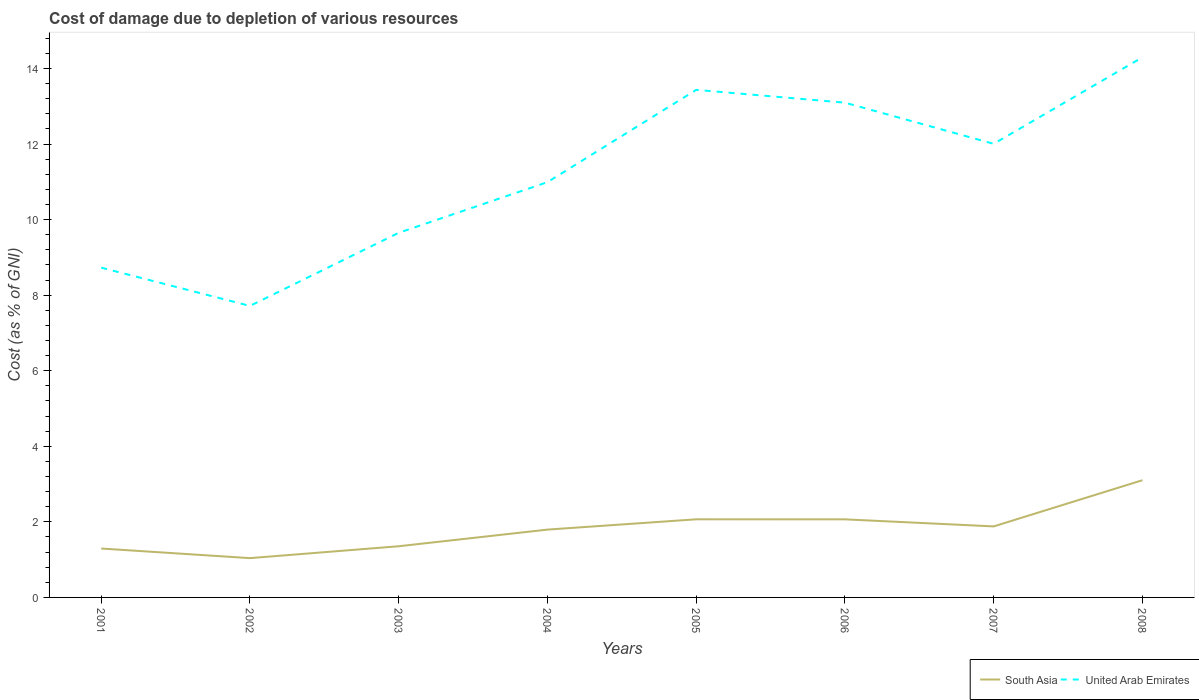How many different coloured lines are there?
Keep it short and to the point. 2. Does the line corresponding to South Asia intersect with the line corresponding to United Arab Emirates?
Keep it short and to the point. No. Across all years, what is the maximum cost of damage caused due to the depletion of various resources in South Asia?
Provide a short and direct response. 1.04. What is the total cost of damage caused due to the depletion of various resources in United Arab Emirates in the graph?
Your answer should be compact. -5.72. What is the difference between the highest and the second highest cost of damage caused due to the depletion of various resources in South Asia?
Offer a very short reply. 2.06. What is the difference between the highest and the lowest cost of damage caused due to the depletion of various resources in United Arab Emirates?
Ensure brevity in your answer.  4. Are the values on the major ticks of Y-axis written in scientific E-notation?
Provide a short and direct response. No. What is the title of the graph?
Keep it short and to the point. Cost of damage due to depletion of various resources. What is the label or title of the Y-axis?
Offer a very short reply. Cost (as % of GNI). What is the Cost (as % of GNI) in South Asia in 2001?
Keep it short and to the point. 1.29. What is the Cost (as % of GNI) in United Arab Emirates in 2001?
Your response must be concise. 8.73. What is the Cost (as % of GNI) in South Asia in 2002?
Ensure brevity in your answer.  1.04. What is the Cost (as % of GNI) of United Arab Emirates in 2002?
Your answer should be compact. 7.72. What is the Cost (as % of GNI) in South Asia in 2003?
Offer a terse response. 1.35. What is the Cost (as % of GNI) of United Arab Emirates in 2003?
Keep it short and to the point. 9.65. What is the Cost (as % of GNI) in South Asia in 2004?
Ensure brevity in your answer.  1.8. What is the Cost (as % of GNI) in United Arab Emirates in 2004?
Provide a short and direct response. 10.99. What is the Cost (as % of GNI) of South Asia in 2005?
Keep it short and to the point. 2.07. What is the Cost (as % of GNI) of United Arab Emirates in 2005?
Your response must be concise. 13.44. What is the Cost (as % of GNI) in South Asia in 2006?
Your response must be concise. 2.07. What is the Cost (as % of GNI) in United Arab Emirates in 2006?
Offer a very short reply. 13.1. What is the Cost (as % of GNI) of South Asia in 2007?
Your response must be concise. 1.88. What is the Cost (as % of GNI) of United Arab Emirates in 2007?
Provide a short and direct response. 12.01. What is the Cost (as % of GNI) of South Asia in 2008?
Make the answer very short. 3.1. What is the Cost (as % of GNI) of United Arab Emirates in 2008?
Provide a succinct answer. 14.3. Across all years, what is the maximum Cost (as % of GNI) in South Asia?
Your answer should be very brief. 3.1. Across all years, what is the maximum Cost (as % of GNI) in United Arab Emirates?
Your answer should be very brief. 14.3. Across all years, what is the minimum Cost (as % of GNI) of South Asia?
Provide a short and direct response. 1.04. Across all years, what is the minimum Cost (as % of GNI) of United Arab Emirates?
Your response must be concise. 7.72. What is the total Cost (as % of GNI) in South Asia in the graph?
Offer a terse response. 14.6. What is the total Cost (as % of GNI) in United Arab Emirates in the graph?
Keep it short and to the point. 89.93. What is the difference between the Cost (as % of GNI) of South Asia in 2001 and that in 2002?
Provide a succinct answer. 0.25. What is the difference between the Cost (as % of GNI) in United Arab Emirates in 2001 and that in 2002?
Offer a terse response. 1.01. What is the difference between the Cost (as % of GNI) in South Asia in 2001 and that in 2003?
Ensure brevity in your answer.  -0.06. What is the difference between the Cost (as % of GNI) in United Arab Emirates in 2001 and that in 2003?
Give a very brief answer. -0.92. What is the difference between the Cost (as % of GNI) in South Asia in 2001 and that in 2004?
Offer a terse response. -0.5. What is the difference between the Cost (as % of GNI) of United Arab Emirates in 2001 and that in 2004?
Give a very brief answer. -2.26. What is the difference between the Cost (as % of GNI) in South Asia in 2001 and that in 2005?
Make the answer very short. -0.77. What is the difference between the Cost (as % of GNI) of United Arab Emirates in 2001 and that in 2005?
Keep it short and to the point. -4.71. What is the difference between the Cost (as % of GNI) in South Asia in 2001 and that in 2006?
Provide a succinct answer. -0.77. What is the difference between the Cost (as % of GNI) in United Arab Emirates in 2001 and that in 2006?
Offer a terse response. -4.37. What is the difference between the Cost (as % of GNI) in South Asia in 2001 and that in 2007?
Offer a terse response. -0.59. What is the difference between the Cost (as % of GNI) of United Arab Emirates in 2001 and that in 2007?
Offer a very short reply. -3.28. What is the difference between the Cost (as % of GNI) of South Asia in 2001 and that in 2008?
Offer a terse response. -1.81. What is the difference between the Cost (as % of GNI) of United Arab Emirates in 2001 and that in 2008?
Keep it short and to the point. -5.57. What is the difference between the Cost (as % of GNI) in South Asia in 2002 and that in 2003?
Offer a terse response. -0.31. What is the difference between the Cost (as % of GNI) in United Arab Emirates in 2002 and that in 2003?
Give a very brief answer. -1.94. What is the difference between the Cost (as % of GNI) of South Asia in 2002 and that in 2004?
Make the answer very short. -0.76. What is the difference between the Cost (as % of GNI) of United Arab Emirates in 2002 and that in 2004?
Offer a terse response. -3.28. What is the difference between the Cost (as % of GNI) of South Asia in 2002 and that in 2005?
Give a very brief answer. -1.03. What is the difference between the Cost (as % of GNI) of United Arab Emirates in 2002 and that in 2005?
Give a very brief answer. -5.72. What is the difference between the Cost (as % of GNI) of South Asia in 2002 and that in 2006?
Your answer should be very brief. -1.03. What is the difference between the Cost (as % of GNI) in United Arab Emirates in 2002 and that in 2006?
Ensure brevity in your answer.  -5.38. What is the difference between the Cost (as % of GNI) in South Asia in 2002 and that in 2007?
Keep it short and to the point. -0.84. What is the difference between the Cost (as % of GNI) of United Arab Emirates in 2002 and that in 2007?
Provide a succinct answer. -4.29. What is the difference between the Cost (as % of GNI) of South Asia in 2002 and that in 2008?
Your answer should be very brief. -2.06. What is the difference between the Cost (as % of GNI) of United Arab Emirates in 2002 and that in 2008?
Make the answer very short. -6.58. What is the difference between the Cost (as % of GNI) in South Asia in 2003 and that in 2004?
Provide a succinct answer. -0.44. What is the difference between the Cost (as % of GNI) of United Arab Emirates in 2003 and that in 2004?
Offer a terse response. -1.34. What is the difference between the Cost (as % of GNI) of South Asia in 2003 and that in 2005?
Keep it short and to the point. -0.71. What is the difference between the Cost (as % of GNI) of United Arab Emirates in 2003 and that in 2005?
Make the answer very short. -3.78. What is the difference between the Cost (as % of GNI) of South Asia in 2003 and that in 2006?
Offer a very short reply. -0.71. What is the difference between the Cost (as % of GNI) of United Arab Emirates in 2003 and that in 2006?
Provide a short and direct response. -3.45. What is the difference between the Cost (as % of GNI) in South Asia in 2003 and that in 2007?
Keep it short and to the point. -0.53. What is the difference between the Cost (as % of GNI) in United Arab Emirates in 2003 and that in 2007?
Provide a short and direct response. -2.36. What is the difference between the Cost (as % of GNI) in South Asia in 2003 and that in 2008?
Give a very brief answer. -1.75. What is the difference between the Cost (as % of GNI) of United Arab Emirates in 2003 and that in 2008?
Provide a succinct answer. -4.65. What is the difference between the Cost (as % of GNI) in South Asia in 2004 and that in 2005?
Ensure brevity in your answer.  -0.27. What is the difference between the Cost (as % of GNI) of United Arab Emirates in 2004 and that in 2005?
Offer a terse response. -2.44. What is the difference between the Cost (as % of GNI) in South Asia in 2004 and that in 2006?
Make the answer very short. -0.27. What is the difference between the Cost (as % of GNI) of United Arab Emirates in 2004 and that in 2006?
Your response must be concise. -2.1. What is the difference between the Cost (as % of GNI) in South Asia in 2004 and that in 2007?
Offer a terse response. -0.08. What is the difference between the Cost (as % of GNI) in United Arab Emirates in 2004 and that in 2007?
Give a very brief answer. -1.01. What is the difference between the Cost (as % of GNI) of South Asia in 2004 and that in 2008?
Offer a terse response. -1.31. What is the difference between the Cost (as % of GNI) of United Arab Emirates in 2004 and that in 2008?
Offer a very short reply. -3.31. What is the difference between the Cost (as % of GNI) in South Asia in 2005 and that in 2006?
Offer a terse response. 0. What is the difference between the Cost (as % of GNI) in United Arab Emirates in 2005 and that in 2006?
Offer a very short reply. 0.34. What is the difference between the Cost (as % of GNI) of South Asia in 2005 and that in 2007?
Ensure brevity in your answer.  0.19. What is the difference between the Cost (as % of GNI) of United Arab Emirates in 2005 and that in 2007?
Ensure brevity in your answer.  1.43. What is the difference between the Cost (as % of GNI) of South Asia in 2005 and that in 2008?
Your answer should be compact. -1.04. What is the difference between the Cost (as % of GNI) of United Arab Emirates in 2005 and that in 2008?
Your answer should be very brief. -0.86. What is the difference between the Cost (as % of GNI) in South Asia in 2006 and that in 2007?
Your answer should be very brief. 0.19. What is the difference between the Cost (as % of GNI) of United Arab Emirates in 2006 and that in 2007?
Ensure brevity in your answer.  1.09. What is the difference between the Cost (as % of GNI) of South Asia in 2006 and that in 2008?
Offer a terse response. -1.04. What is the difference between the Cost (as % of GNI) of United Arab Emirates in 2006 and that in 2008?
Keep it short and to the point. -1.2. What is the difference between the Cost (as % of GNI) in South Asia in 2007 and that in 2008?
Give a very brief answer. -1.22. What is the difference between the Cost (as % of GNI) of United Arab Emirates in 2007 and that in 2008?
Your answer should be compact. -2.29. What is the difference between the Cost (as % of GNI) of South Asia in 2001 and the Cost (as % of GNI) of United Arab Emirates in 2002?
Your response must be concise. -6.42. What is the difference between the Cost (as % of GNI) of South Asia in 2001 and the Cost (as % of GNI) of United Arab Emirates in 2003?
Provide a succinct answer. -8.36. What is the difference between the Cost (as % of GNI) of South Asia in 2001 and the Cost (as % of GNI) of United Arab Emirates in 2004?
Keep it short and to the point. -9.7. What is the difference between the Cost (as % of GNI) in South Asia in 2001 and the Cost (as % of GNI) in United Arab Emirates in 2005?
Keep it short and to the point. -12.14. What is the difference between the Cost (as % of GNI) in South Asia in 2001 and the Cost (as % of GNI) in United Arab Emirates in 2006?
Your answer should be very brief. -11.8. What is the difference between the Cost (as % of GNI) of South Asia in 2001 and the Cost (as % of GNI) of United Arab Emirates in 2007?
Your answer should be compact. -10.71. What is the difference between the Cost (as % of GNI) of South Asia in 2001 and the Cost (as % of GNI) of United Arab Emirates in 2008?
Offer a very short reply. -13. What is the difference between the Cost (as % of GNI) of South Asia in 2002 and the Cost (as % of GNI) of United Arab Emirates in 2003?
Give a very brief answer. -8.61. What is the difference between the Cost (as % of GNI) of South Asia in 2002 and the Cost (as % of GNI) of United Arab Emirates in 2004?
Keep it short and to the point. -9.95. What is the difference between the Cost (as % of GNI) of South Asia in 2002 and the Cost (as % of GNI) of United Arab Emirates in 2005?
Offer a very short reply. -12.4. What is the difference between the Cost (as % of GNI) in South Asia in 2002 and the Cost (as % of GNI) in United Arab Emirates in 2006?
Keep it short and to the point. -12.06. What is the difference between the Cost (as % of GNI) of South Asia in 2002 and the Cost (as % of GNI) of United Arab Emirates in 2007?
Your answer should be compact. -10.97. What is the difference between the Cost (as % of GNI) of South Asia in 2002 and the Cost (as % of GNI) of United Arab Emirates in 2008?
Ensure brevity in your answer.  -13.26. What is the difference between the Cost (as % of GNI) of South Asia in 2003 and the Cost (as % of GNI) of United Arab Emirates in 2004?
Your answer should be compact. -9.64. What is the difference between the Cost (as % of GNI) of South Asia in 2003 and the Cost (as % of GNI) of United Arab Emirates in 2005?
Give a very brief answer. -12.08. What is the difference between the Cost (as % of GNI) of South Asia in 2003 and the Cost (as % of GNI) of United Arab Emirates in 2006?
Make the answer very short. -11.74. What is the difference between the Cost (as % of GNI) in South Asia in 2003 and the Cost (as % of GNI) in United Arab Emirates in 2007?
Your response must be concise. -10.65. What is the difference between the Cost (as % of GNI) of South Asia in 2003 and the Cost (as % of GNI) of United Arab Emirates in 2008?
Provide a succinct answer. -12.94. What is the difference between the Cost (as % of GNI) of South Asia in 2004 and the Cost (as % of GNI) of United Arab Emirates in 2005?
Keep it short and to the point. -11.64. What is the difference between the Cost (as % of GNI) of South Asia in 2004 and the Cost (as % of GNI) of United Arab Emirates in 2006?
Your response must be concise. -11.3. What is the difference between the Cost (as % of GNI) in South Asia in 2004 and the Cost (as % of GNI) in United Arab Emirates in 2007?
Give a very brief answer. -10.21. What is the difference between the Cost (as % of GNI) in South Asia in 2004 and the Cost (as % of GNI) in United Arab Emirates in 2008?
Offer a terse response. -12.5. What is the difference between the Cost (as % of GNI) of South Asia in 2005 and the Cost (as % of GNI) of United Arab Emirates in 2006?
Provide a short and direct response. -11.03. What is the difference between the Cost (as % of GNI) in South Asia in 2005 and the Cost (as % of GNI) in United Arab Emirates in 2007?
Keep it short and to the point. -9.94. What is the difference between the Cost (as % of GNI) in South Asia in 2005 and the Cost (as % of GNI) in United Arab Emirates in 2008?
Provide a short and direct response. -12.23. What is the difference between the Cost (as % of GNI) in South Asia in 2006 and the Cost (as % of GNI) in United Arab Emirates in 2007?
Your response must be concise. -9.94. What is the difference between the Cost (as % of GNI) in South Asia in 2006 and the Cost (as % of GNI) in United Arab Emirates in 2008?
Offer a terse response. -12.23. What is the difference between the Cost (as % of GNI) in South Asia in 2007 and the Cost (as % of GNI) in United Arab Emirates in 2008?
Provide a short and direct response. -12.42. What is the average Cost (as % of GNI) in South Asia per year?
Offer a very short reply. 1.83. What is the average Cost (as % of GNI) in United Arab Emirates per year?
Provide a succinct answer. 11.24. In the year 2001, what is the difference between the Cost (as % of GNI) in South Asia and Cost (as % of GNI) in United Arab Emirates?
Your answer should be compact. -7.43. In the year 2002, what is the difference between the Cost (as % of GNI) in South Asia and Cost (as % of GNI) in United Arab Emirates?
Offer a terse response. -6.68. In the year 2003, what is the difference between the Cost (as % of GNI) in South Asia and Cost (as % of GNI) in United Arab Emirates?
Offer a very short reply. -8.3. In the year 2004, what is the difference between the Cost (as % of GNI) in South Asia and Cost (as % of GNI) in United Arab Emirates?
Provide a short and direct response. -9.2. In the year 2005, what is the difference between the Cost (as % of GNI) in South Asia and Cost (as % of GNI) in United Arab Emirates?
Ensure brevity in your answer.  -11.37. In the year 2006, what is the difference between the Cost (as % of GNI) in South Asia and Cost (as % of GNI) in United Arab Emirates?
Provide a short and direct response. -11.03. In the year 2007, what is the difference between the Cost (as % of GNI) of South Asia and Cost (as % of GNI) of United Arab Emirates?
Your answer should be compact. -10.13. In the year 2008, what is the difference between the Cost (as % of GNI) of South Asia and Cost (as % of GNI) of United Arab Emirates?
Provide a short and direct response. -11.19. What is the ratio of the Cost (as % of GNI) in South Asia in 2001 to that in 2002?
Your answer should be very brief. 1.24. What is the ratio of the Cost (as % of GNI) of United Arab Emirates in 2001 to that in 2002?
Offer a very short reply. 1.13. What is the ratio of the Cost (as % of GNI) in South Asia in 2001 to that in 2003?
Give a very brief answer. 0.96. What is the ratio of the Cost (as % of GNI) in United Arab Emirates in 2001 to that in 2003?
Your response must be concise. 0.9. What is the ratio of the Cost (as % of GNI) in South Asia in 2001 to that in 2004?
Offer a terse response. 0.72. What is the ratio of the Cost (as % of GNI) in United Arab Emirates in 2001 to that in 2004?
Keep it short and to the point. 0.79. What is the ratio of the Cost (as % of GNI) in South Asia in 2001 to that in 2005?
Make the answer very short. 0.63. What is the ratio of the Cost (as % of GNI) of United Arab Emirates in 2001 to that in 2005?
Offer a very short reply. 0.65. What is the ratio of the Cost (as % of GNI) of South Asia in 2001 to that in 2006?
Your answer should be compact. 0.63. What is the ratio of the Cost (as % of GNI) in United Arab Emirates in 2001 to that in 2006?
Offer a very short reply. 0.67. What is the ratio of the Cost (as % of GNI) of South Asia in 2001 to that in 2007?
Provide a short and direct response. 0.69. What is the ratio of the Cost (as % of GNI) of United Arab Emirates in 2001 to that in 2007?
Provide a succinct answer. 0.73. What is the ratio of the Cost (as % of GNI) in South Asia in 2001 to that in 2008?
Provide a succinct answer. 0.42. What is the ratio of the Cost (as % of GNI) in United Arab Emirates in 2001 to that in 2008?
Ensure brevity in your answer.  0.61. What is the ratio of the Cost (as % of GNI) of South Asia in 2002 to that in 2003?
Provide a short and direct response. 0.77. What is the ratio of the Cost (as % of GNI) in United Arab Emirates in 2002 to that in 2003?
Provide a succinct answer. 0.8. What is the ratio of the Cost (as % of GNI) in South Asia in 2002 to that in 2004?
Make the answer very short. 0.58. What is the ratio of the Cost (as % of GNI) in United Arab Emirates in 2002 to that in 2004?
Make the answer very short. 0.7. What is the ratio of the Cost (as % of GNI) of South Asia in 2002 to that in 2005?
Ensure brevity in your answer.  0.5. What is the ratio of the Cost (as % of GNI) of United Arab Emirates in 2002 to that in 2005?
Provide a succinct answer. 0.57. What is the ratio of the Cost (as % of GNI) in South Asia in 2002 to that in 2006?
Your response must be concise. 0.5. What is the ratio of the Cost (as % of GNI) in United Arab Emirates in 2002 to that in 2006?
Make the answer very short. 0.59. What is the ratio of the Cost (as % of GNI) of South Asia in 2002 to that in 2007?
Provide a succinct answer. 0.55. What is the ratio of the Cost (as % of GNI) of United Arab Emirates in 2002 to that in 2007?
Ensure brevity in your answer.  0.64. What is the ratio of the Cost (as % of GNI) of South Asia in 2002 to that in 2008?
Your answer should be very brief. 0.34. What is the ratio of the Cost (as % of GNI) in United Arab Emirates in 2002 to that in 2008?
Provide a short and direct response. 0.54. What is the ratio of the Cost (as % of GNI) in South Asia in 2003 to that in 2004?
Your answer should be very brief. 0.75. What is the ratio of the Cost (as % of GNI) in United Arab Emirates in 2003 to that in 2004?
Your response must be concise. 0.88. What is the ratio of the Cost (as % of GNI) of South Asia in 2003 to that in 2005?
Ensure brevity in your answer.  0.66. What is the ratio of the Cost (as % of GNI) in United Arab Emirates in 2003 to that in 2005?
Keep it short and to the point. 0.72. What is the ratio of the Cost (as % of GNI) in South Asia in 2003 to that in 2006?
Your response must be concise. 0.66. What is the ratio of the Cost (as % of GNI) of United Arab Emirates in 2003 to that in 2006?
Provide a short and direct response. 0.74. What is the ratio of the Cost (as % of GNI) in South Asia in 2003 to that in 2007?
Give a very brief answer. 0.72. What is the ratio of the Cost (as % of GNI) of United Arab Emirates in 2003 to that in 2007?
Your answer should be compact. 0.8. What is the ratio of the Cost (as % of GNI) of South Asia in 2003 to that in 2008?
Make the answer very short. 0.44. What is the ratio of the Cost (as % of GNI) in United Arab Emirates in 2003 to that in 2008?
Give a very brief answer. 0.68. What is the ratio of the Cost (as % of GNI) in South Asia in 2004 to that in 2005?
Offer a terse response. 0.87. What is the ratio of the Cost (as % of GNI) in United Arab Emirates in 2004 to that in 2005?
Give a very brief answer. 0.82. What is the ratio of the Cost (as % of GNI) of South Asia in 2004 to that in 2006?
Give a very brief answer. 0.87. What is the ratio of the Cost (as % of GNI) of United Arab Emirates in 2004 to that in 2006?
Provide a succinct answer. 0.84. What is the ratio of the Cost (as % of GNI) of South Asia in 2004 to that in 2007?
Your response must be concise. 0.95. What is the ratio of the Cost (as % of GNI) of United Arab Emirates in 2004 to that in 2007?
Make the answer very short. 0.92. What is the ratio of the Cost (as % of GNI) in South Asia in 2004 to that in 2008?
Your answer should be compact. 0.58. What is the ratio of the Cost (as % of GNI) in United Arab Emirates in 2004 to that in 2008?
Give a very brief answer. 0.77. What is the ratio of the Cost (as % of GNI) in South Asia in 2005 to that in 2006?
Your answer should be very brief. 1. What is the ratio of the Cost (as % of GNI) in United Arab Emirates in 2005 to that in 2006?
Provide a succinct answer. 1.03. What is the ratio of the Cost (as % of GNI) of South Asia in 2005 to that in 2007?
Your answer should be compact. 1.1. What is the ratio of the Cost (as % of GNI) in United Arab Emirates in 2005 to that in 2007?
Offer a very short reply. 1.12. What is the ratio of the Cost (as % of GNI) of South Asia in 2005 to that in 2008?
Your answer should be compact. 0.67. What is the ratio of the Cost (as % of GNI) of United Arab Emirates in 2005 to that in 2008?
Provide a short and direct response. 0.94. What is the ratio of the Cost (as % of GNI) in South Asia in 2006 to that in 2007?
Your answer should be very brief. 1.1. What is the ratio of the Cost (as % of GNI) in United Arab Emirates in 2006 to that in 2007?
Your answer should be compact. 1.09. What is the ratio of the Cost (as % of GNI) of South Asia in 2006 to that in 2008?
Your answer should be compact. 0.67. What is the ratio of the Cost (as % of GNI) of United Arab Emirates in 2006 to that in 2008?
Your answer should be compact. 0.92. What is the ratio of the Cost (as % of GNI) of South Asia in 2007 to that in 2008?
Your answer should be very brief. 0.61. What is the ratio of the Cost (as % of GNI) in United Arab Emirates in 2007 to that in 2008?
Ensure brevity in your answer.  0.84. What is the difference between the highest and the second highest Cost (as % of GNI) of South Asia?
Ensure brevity in your answer.  1.04. What is the difference between the highest and the second highest Cost (as % of GNI) of United Arab Emirates?
Offer a very short reply. 0.86. What is the difference between the highest and the lowest Cost (as % of GNI) in South Asia?
Keep it short and to the point. 2.06. What is the difference between the highest and the lowest Cost (as % of GNI) of United Arab Emirates?
Keep it short and to the point. 6.58. 